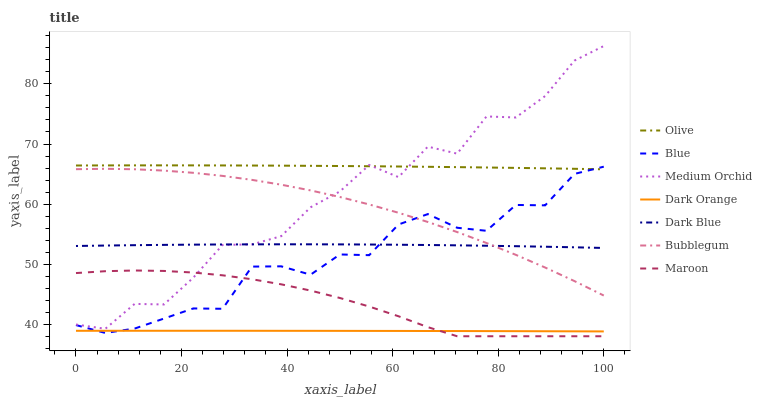Does Medium Orchid have the minimum area under the curve?
Answer yes or no. No. Does Medium Orchid have the maximum area under the curve?
Answer yes or no. No. Is Medium Orchid the smoothest?
Answer yes or no. No. Is Dark Orange the roughest?
Answer yes or no. No. Does Dark Orange have the lowest value?
Answer yes or no. No. Does Dark Orange have the highest value?
Answer yes or no. No. Is Dark Orange less than Olive?
Answer yes or no. Yes. Is Olive greater than Bubblegum?
Answer yes or no. Yes. Does Dark Orange intersect Olive?
Answer yes or no. No. 